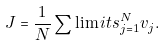<formula> <loc_0><loc_0><loc_500><loc_500>J = { \frac { 1 } { N } } \sum \lim i t s _ { j = 1 } ^ { N } { v _ { j } } .</formula> 